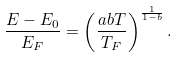<formula> <loc_0><loc_0><loc_500><loc_500>\frac { E - E _ { 0 } } { E _ { F } } = \left ( \frac { a b T } { T _ { F } } \right ) ^ { \frac { 1 } { 1 - b } } .</formula> 